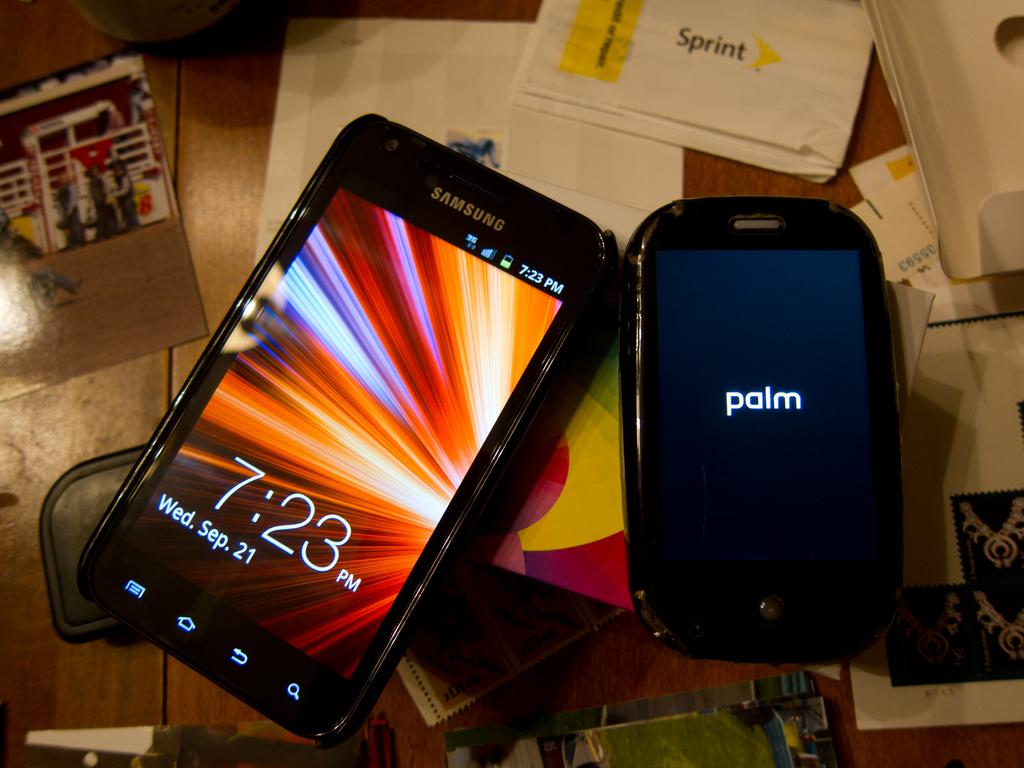<image>
Summarize the visual content of the image. a samsung phone is laying by a palm device on a desk 